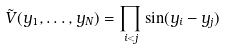<formula> <loc_0><loc_0><loc_500><loc_500>\tilde { V } ( y _ { 1 } , \dots , y _ { N } ) = \prod _ { i < j } \sin ( y _ { i } - y _ { j } )</formula> 